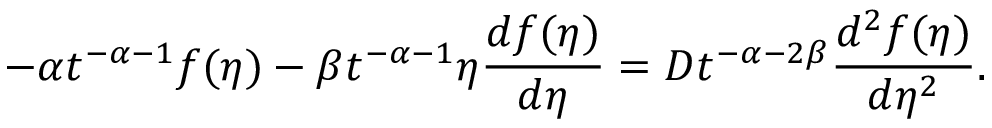<formula> <loc_0><loc_0><loc_500><loc_500>- \alpha t ^ { - \alpha - 1 } f ( \eta ) - \beta t ^ { - \alpha - 1 } \eta \frac { d f ( \eta ) } { d \eta } = D t ^ { - \alpha - 2 \beta } \frac { d ^ { 2 } f ( \eta ) } { d \eta ^ { 2 } } .</formula> 